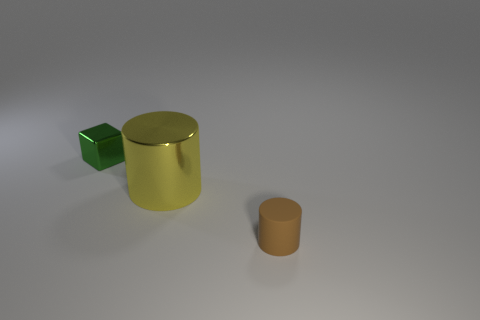Is there a tiny brown rubber object behind the small object behind the large yellow metal cylinder?
Your response must be concise. No. What number of tiny metallic cubes are behind the small thing to the left of the tiny rubber object that is in front of the yellow metal cylinder?
Your answer should be very brief. 0. The object that is both to the left of the tiny cylinder and right of the small green block is what color?
Offer a very short reply. Yellow. What number of things are the same color as the large cylinder?
Ensure brevity in your answer.  0. What number of blocks are big green metallic things or big yellow objects?
Your answer should be compact. 0. The metal cube that is the same size as the brown thing is what color?
Offer a terse response. Green. There is a tiny object that is in front of the small object that is left of the yellow metal cylinder; is there a yellow object on the left side of it?
Make the answer very short. Yes. What size is the yellow object?
Your response must be concise. Large. What number of things are tiny brown objects or big cylinders?
Offer a terse response. 2. There is another thing that is the same material as the big object; what color is it?
Provide a short and direct response. Green. 